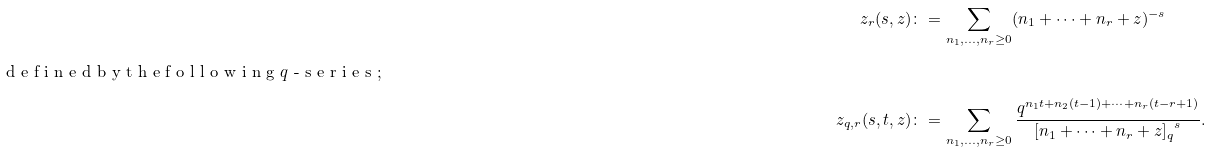<formula> <loc_0><loc_0><loc_500><loc_500>\ z _ { r } ( s , z ) \colon & = \sum _ { n _ { 1 } , \dots , n _ { r } \geq 0 } ( n _ { 1 } + \cdots + n _ { r } + z ) ^ { - s } \intertext { d e f i n e d b y t h e f o l l o w i n g $ q $ - s e r i e s ; } \ z _ { q , r } ( s , t , z ) \colon & = \sum _ { n _ { 1 } , \dots , n _ { r } \geq 0 } \frac { q ^ { n _ { 1 } t + n _ { 2 } ( t - 1 ) + \cdots + n _ { r } ( t - r + 1 ) } } { { [ n _ { 1 } + \cdots + n _ { r } + z ] _ { q } } ^ { s } } .</formula> 